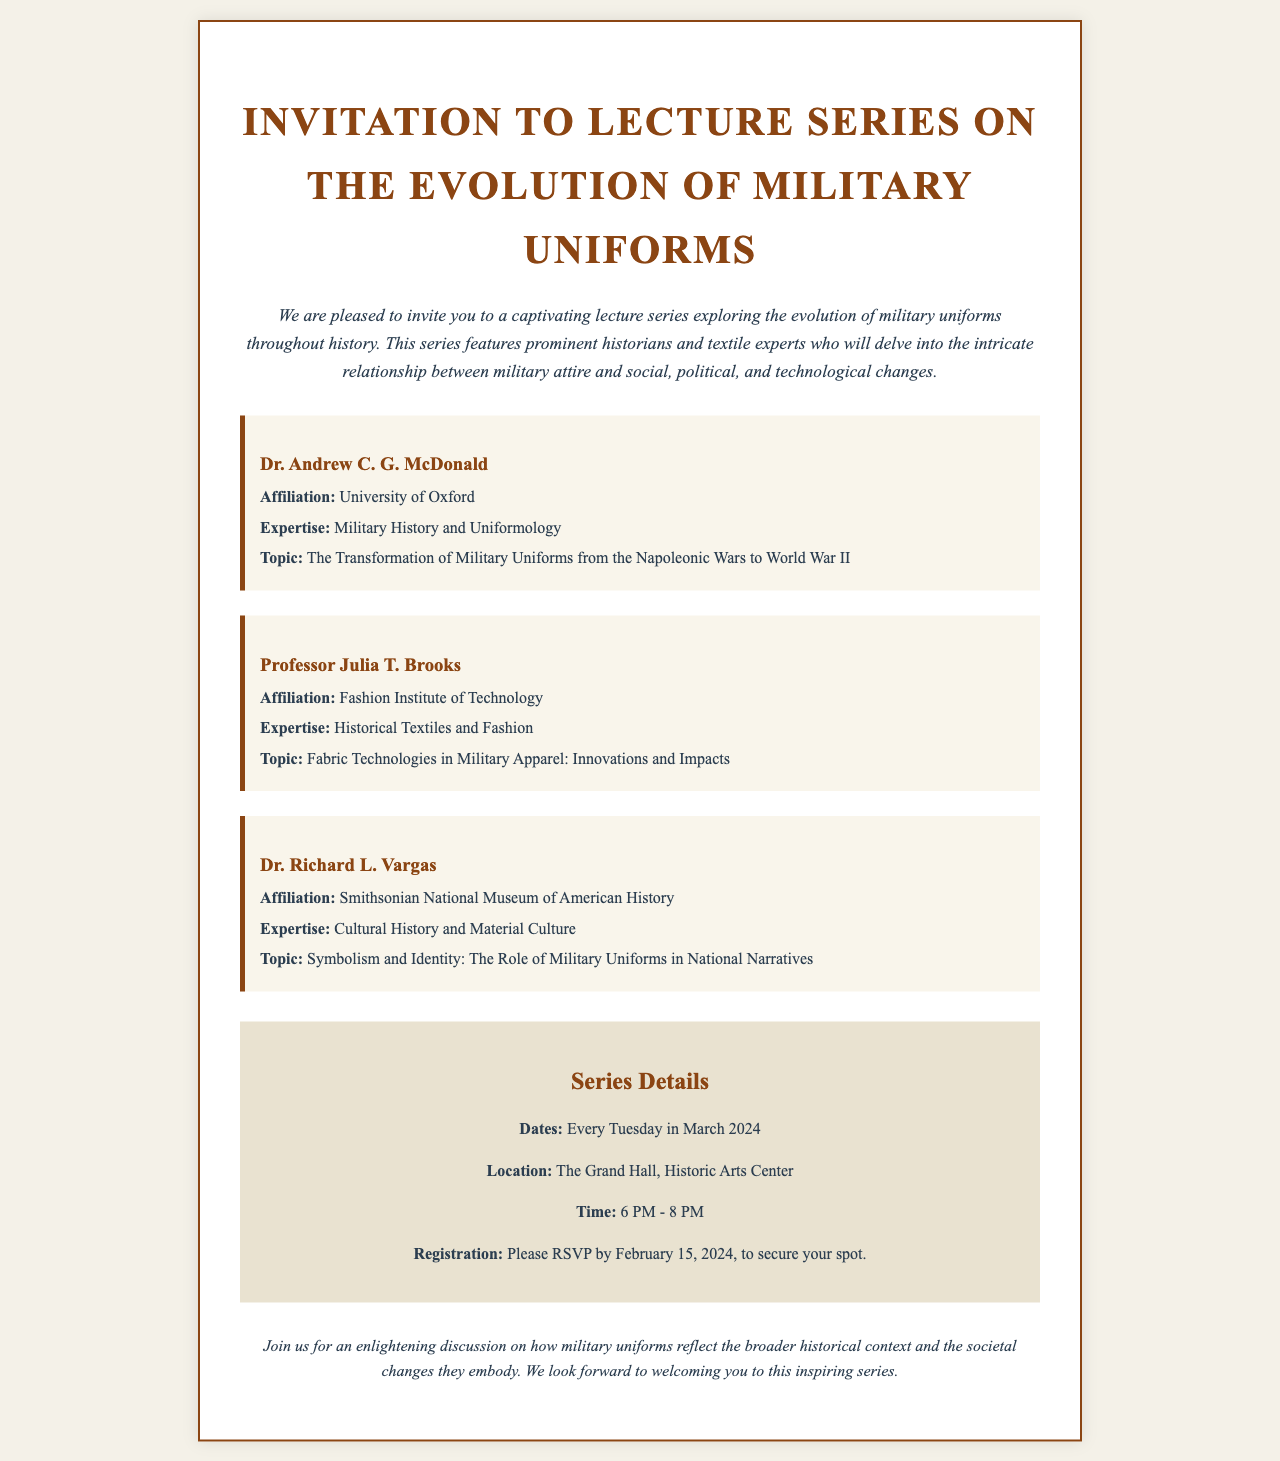What is the title of the lecture series? The title of the lecture series is explicitly mentioned at the top of the document.
Answer: Invitation to Lecture Series on the Evolution of Military Uniforms Who is the speaker affiliated with the University of Oxford? The document lists speakers along with their affiliations, which allows for easy identification.
Answer: Dr. Andrew C. G. McDonald What day of the week will the lectures occur? The document states that the lectures will take place every Tuesday.
Answer: Tuesday How many speakers are featured in the series? The number of speakers can be counted from the sections listed in the document.
Answer: Three What is the final date to RSVP for the event? The RSVP deadline is clearly indicated in the details section of the document.
Answer: February 15, 2024 What is Dr. Richard L. Vargas's topic of discussion? The specific topic assigned to each speaker is provided in their individual descriptions.
Answer: Symbolism and Identity: The Role of Military Uniforms in National Narratives Where will the lecture series be held? The location of the event is described in the details section of the document.
Answer: The Grand Hall, Historic Arts Center What month will the lecture series take place? The month is indicated in the series details, providing a timeframe for the event.
Answer: March 2024 